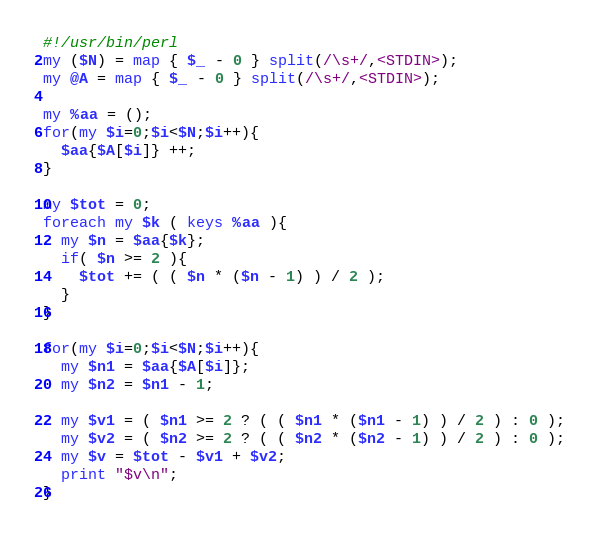<code> <loc_0><loc_0><loc_500><loc_500><_Perl_>#!/usr/bin/perl
my ($N) = map { $_ - 0 } split(/\s+/,<STDIN>);
my @A = map { $_ - 0 } split(/\s+/,<STDIN>);

my %aa = ();
for(my $i=0;$i<$N;$i++){
  $aa{$A[$i]} ++;
}

my $tot = 0;
foreach my $k ( keys %aa ){
  my $n = $aa{$k};
  if( $n >= 2 ){
    $tot += ( ( $n * ($n - 1) ) / 2 );
  }
}

for(my $i=0;$i<$N;$i++){
  my $n1 = $aa{$A[$i]};
  my $n2 = $n1 - 1;
  
  my $v1 = ( $n1 >= 2 ? ( ( $n1 * ($n1 - 1) ) / 2 ) : 0 );
  my $v2 = ( $n2 >= 2 ? ( ( $n2 * ($n2 - 1) ) / 2 ) : 0 );
  my $v = $tot - $v1 + $v2;
  print "$v\n";
}


</code> 